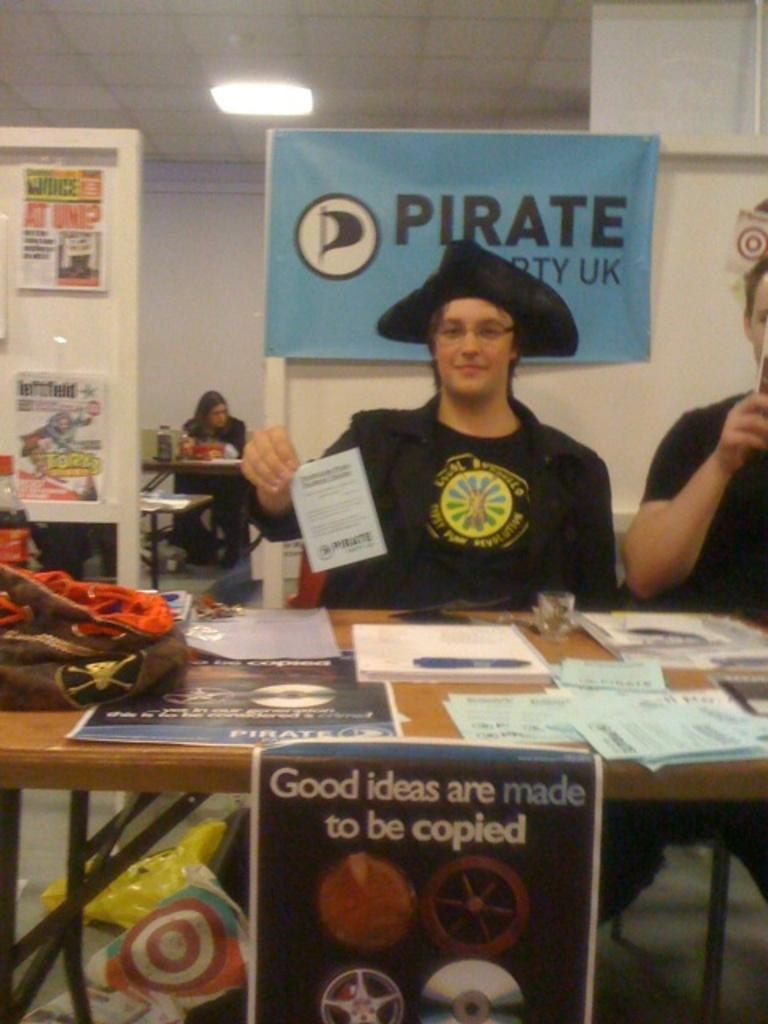<image>
Render a clear and concise summary of the photo. Someone in a pirate hat sits at a table in front of a sign that says PIRATE and has an icon of a black flag. 